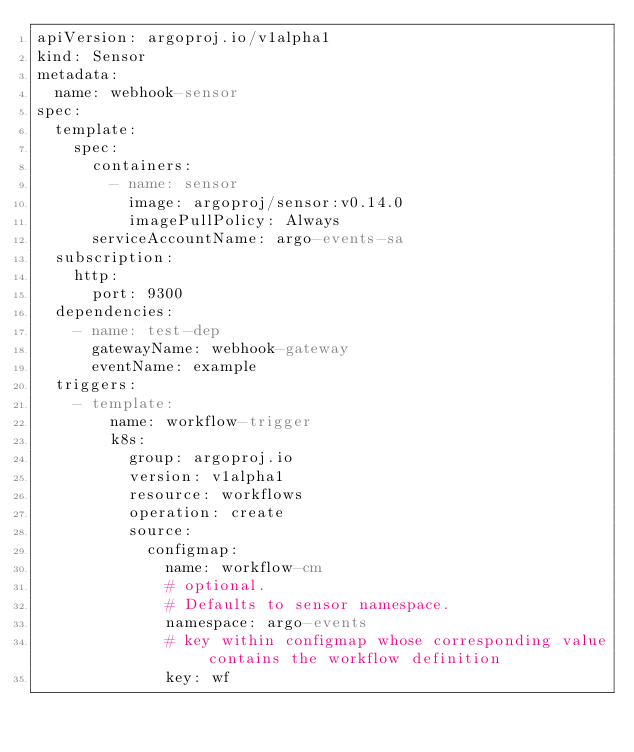<code> <loc_0><loc_0><loc_500><loc_500><_YAML_>apiVersion: argoproj.io/v1alpha1
kind: Sensor
metadata:
  name: webhook-sensor
spec:
  template:
    spec:
      containers:
        - name: sensor
          image: argoproj/sensor:v0.14.0
          imagePullPolicy: Always
      serviceAccountName: argo-events-sa
  subscription:
    http:
      port: 9300
  dependencies:
    - name: test-dep
      gatewayName: webhook-gateway
      eventName: example
  triggers:
    - template:
        name: workflow-trigger
        k8s:
          group: argoproj.io
          version: v1alpha1
          resource: workflows
          operation: create
          source:
            configmap:
              name: workflow-cm
              # optional.
              # Defaults to sensor namespace.
              namespace: argo-events
              # key within configmap whose corresponding value contains the workflow definition
              key: wf
</code> 